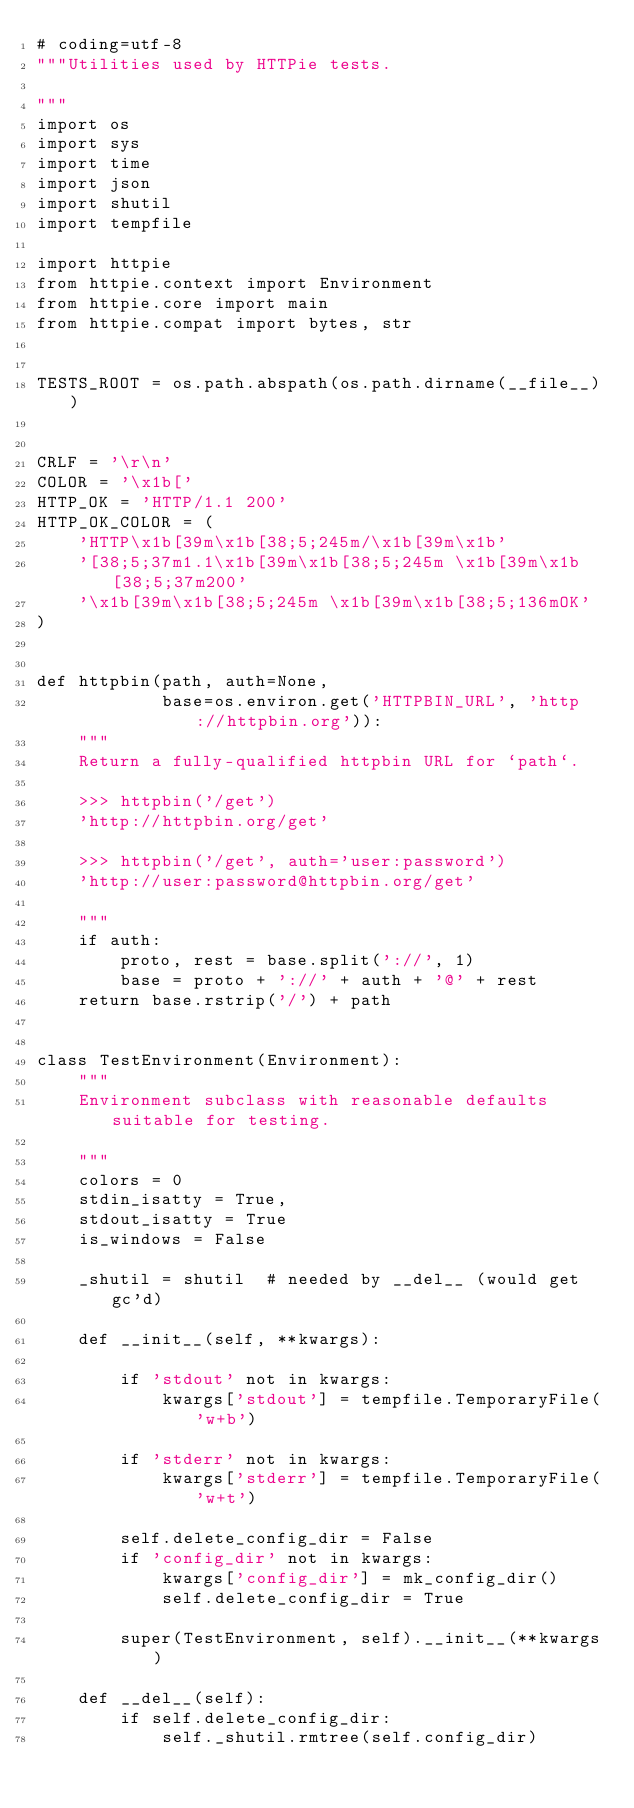<code> <loc_0><loc_0><loc_500><loc_500><_Python_># coding=utf-8
"""Utilities used by HTTPie tests.

"""
import os
import sys
import time
import json
import shutil
import tempfile

import httpie
from httpie.context import Environment
from httpie.core import main
from httpie.compat import bytes, str


TESTS_ROOT = os.path.abspath(os.path.dirname(__file__))


CRLF = '\r\n'
COLOR = '\x1b['
HTTP_OK = 'HTTP/1.1 200'
HTTP_OK_COLOR = (
    'HTTP\x1b[39m\x1b[38;5;245m/\x1b[39m\x1b'
    '[38;5;37m1.1\x1b[39m\x1b[38;5;245m \x1b[39m\x1b[38;5;37m200'
    '\x1b[39m\x1b[38;5;245m \x1b[39m\x1b[38;5;136mOK'
)


def httpbin(path, auth=None,
            base=os.environ.get('HTTPBIN_URL', 'http://httpbin.org')):
    """
    Return a fully-qualified httpbin URL for `path`.

    >>> httpbin('/get')
    'http://httpbin.org/get'

    >>> httpbin('/get', auth='user:password')
    'http://user:password@httpbin.org/get'

    """
    if auth:
        proto, rest = base.split('://', 1)
        base = proto + '://' + auth + '@' + rest
    return base.rstrip('/') + path


class TestEnvironment(Environment):
    """
    Environment subclass with reasonable defaults suitable for testing.

    """
    colors = 0
    stdin_isatty = True,
    stdout_isatty = True
    is_windows = False

    _shutil = shutil  # needed by __del__ (would get gc'd)

    def __init__(self, **kwargs):

        if 'stdout' not in kwargs:
            kwargs['stdout'] = tempfile.TemporaryFile('w+b')

        if 'stderr' not in kwargs:
            kwargs['stderr'] = tempfile.TemporaryFile('w+t')

        self.delete_config_dir = False
        if 'config_dir' not in kwargs:
            kwargs['config_dir'] = mk_config_dir()
            self.delete_config_dir = True

        super(TestEnvironment, self).__init__(**kwargs)

    def __del__(self):
        if self.delete_config_dir:
            self._shutil.rmtree(self.config_dir)

</code> 